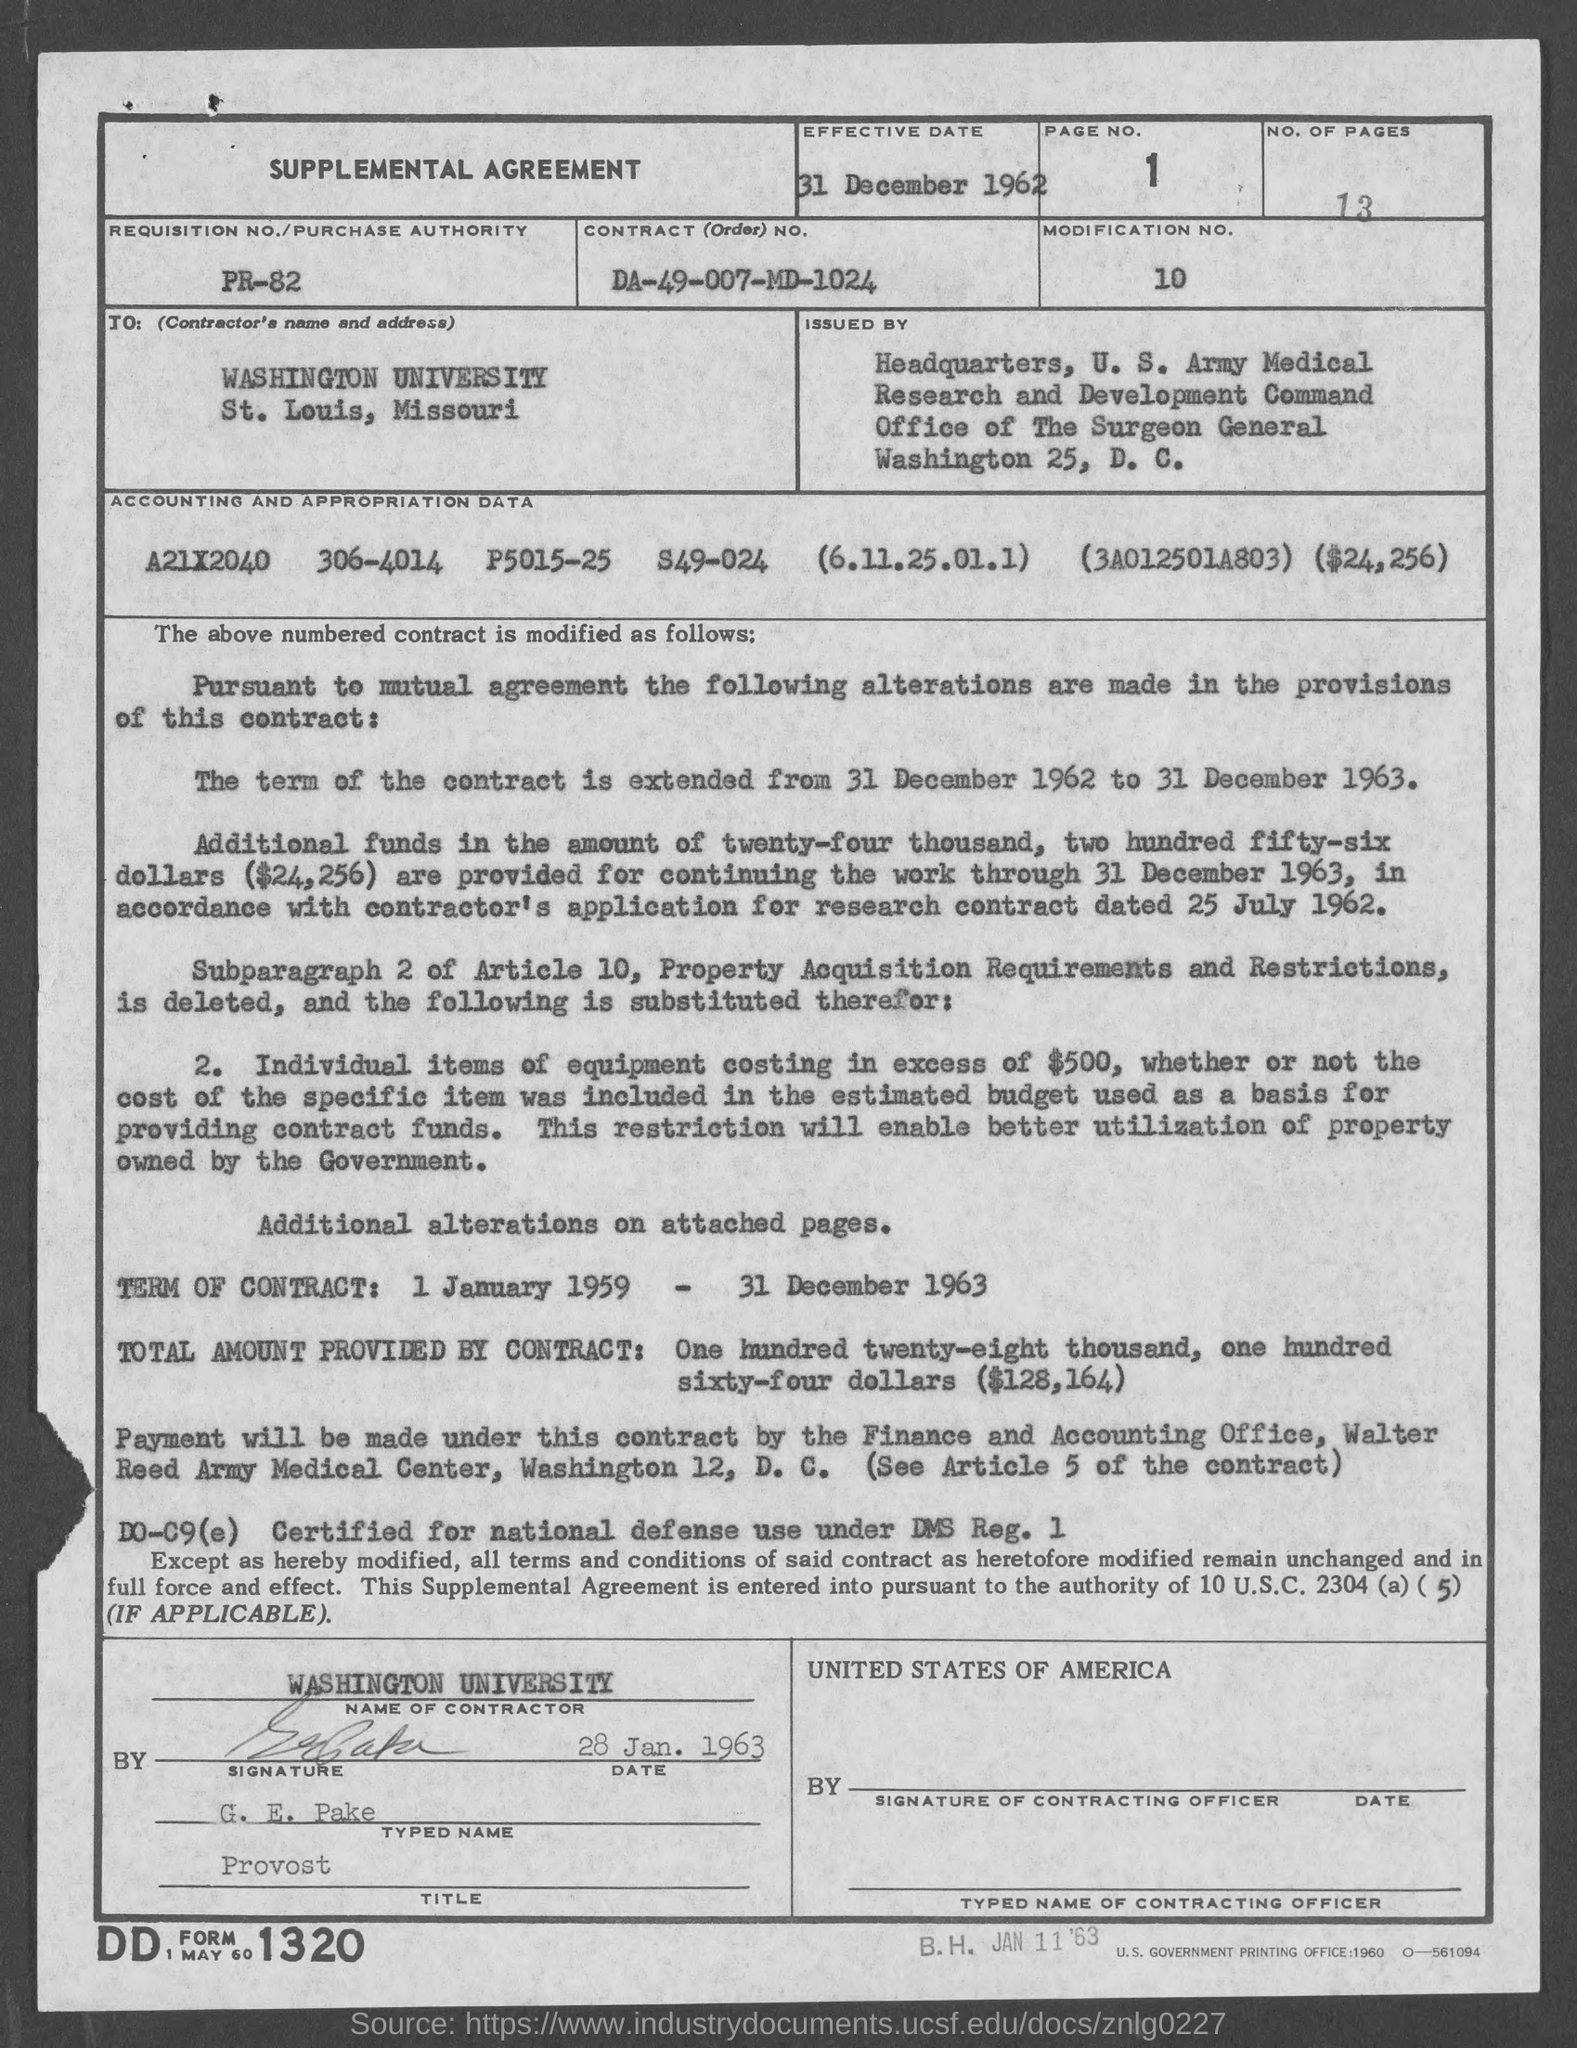What is the page number on this document? The page number on the document is 1. This information is clearly displayed in the top-right corner beside the 'PAGE NO.' label. 